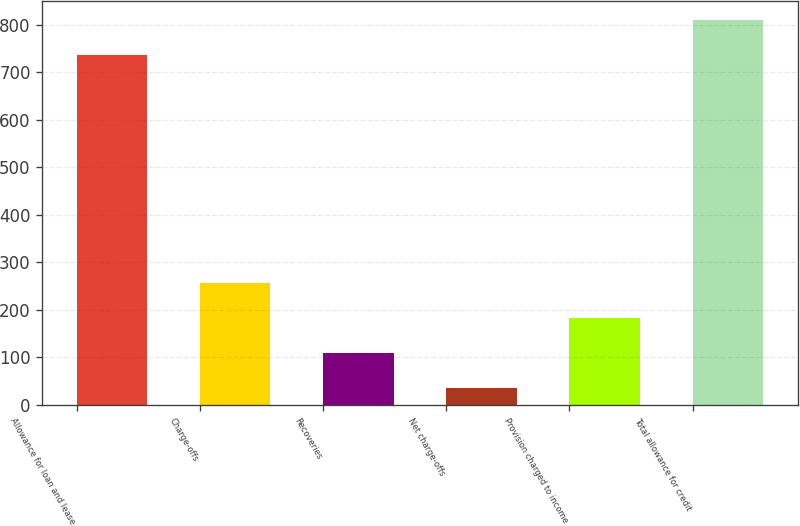Convert chart. <chart><loc_0><loc_0><loc_500><loc_500><bar_chart><fcel>Allowance for loan and lease<fcel>Charge-offs<fcel>Recoveries<fcel>Net charge-offs<fcel>Provision charged to income<fcel>Total allowance for credit<nl><fcel>736.8<fcel>256.4<fcel>108.8<fcel>35<fcel>182.6<fcel>810.6<nl></chart> 